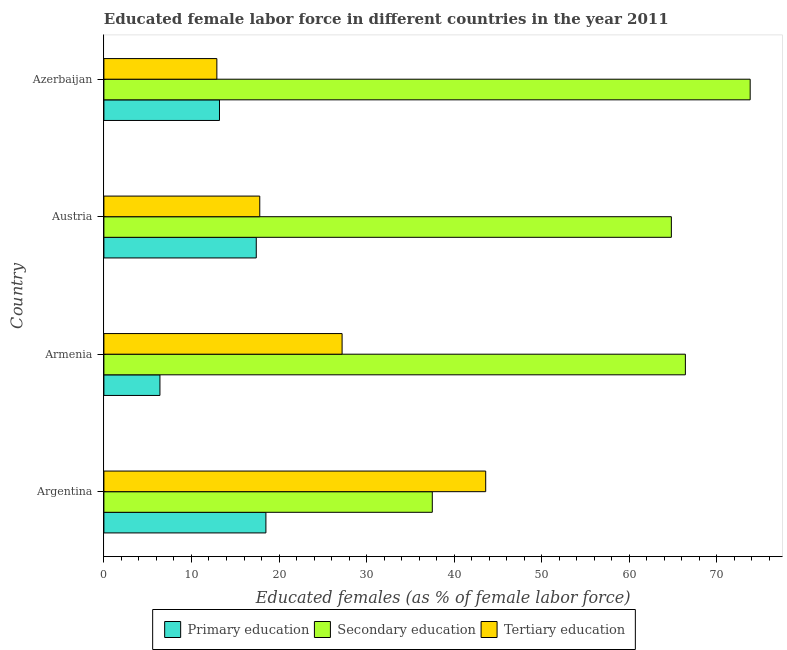How many groups of bars are there?
Provide a succinct answer. 4. What is the label of the 4th group of bars from the top?
Your answer should be compact. Argentina. In how many cases, is the number of bars for a given country not equal to the number of legend labels?
Offer a terse response. 0. What is the percentage of female labor force who received tertiary education in Azerbaijan?
Ensure brevity in your answer.  12.9. Across all countries, what is the maximum percentage of female labor force who received secondary education?
Provide a short and direct response. 73.8. Across all countries, what is the minimum percentage of female labor force who received tertiary education?
Offer a terse response. 12.9. In which country was the percentage of female labor force who received secondary education minimum?
Offer a very short reply. Argentina. What is the total percentage of female labor force who received secondary education in the graph?
Ensure brevity in your answer.  242.5. What is the difference between the percentage of female labor force who received tertiary education in Argentina and that in Austria?
Keep it short and to the point. 25.8. What is the difference between the percentage of female labor force who received secondary education in Austria and the percentage of female labor force who received primary education in Armenia?
Make the answer very short. 58.4. What is the average percentage of female labor force who received primary education per country?
Your answer should be compact. 13.88. What is the difference between the percentage of female labor force who received primary education and percentage of female labor force who received tertiary education in Argentina?
Your answer should be compact. -25.1. What is the ratio of the percentage of female labor force who received tertiary education in Argentina to that in Austria?
Your response must be concise. 2.45. What is the difference between the highest and the lowest percentage of female labor force who received tertiary education?
Your answer should be very brief. 30.7. In how many countries, is the percentage of female labor force who received primary education greater than the average percentage of female labor force who received primary education taken over all countries?
Give a very brief answer. 2. Is the sum of the percentage of female labor force who received tertiary education in Argentina and Austria greater than the maximum percentage of female labor force who received secondary education across all countries?
Offer a very short reply. No. What does the 3rd bar from the bottom in Austria represents?
Your answer should be very brief. Tertiary education. Are all the bars in the graph horizontal?
Give a very brief answer. Yes. How many countries are there in the graph?
Offer a very short reply. 4. What is the difference between two consecutive major ticks on the X-axis?
Give a very brief answer. 10. Are the values on the major ticks of X-axis written in scientific E-notation?
Give a very brief answer. No. Does the graph contain grids?
Offer a very short reply. No. What is the title of the graph?
Provide a succinct answer. Educated female labor force in different countries in the year 2011. Does "Solid fuel" appear as one of the legend labels in the graph?
Your answer should be very brief. No. What is the label or title of the X-axis?
Give a very brief answer. Educated females (as % of female labor force). What is the label or title of the Y-axis?
Your answer should be compact. Country. What is the Educated females (as % of female labor force) in Primary education in Argentina?
Ensure brevity in your answer.  18.5. What is the Educated females (as % of female labor force) in Secondary education in Argentina?
Your response must be concise. 37.5. What is the Educated females (as % of female labor force) of Tertiary education in Argentina?
Offer a very short reply. 43.6. What is the Educated females (as % of female labor force) of Primary education in Armenia?
Your answer should be very brief. 6.4. What is the Educated females (as % of female labor force) in Secondary education in Armenia?
Offer a very short reply. 66.4. What is the Educated females (as % of female labor force) of Tertiary education in Armenia?
Make the answer very short. 27.2. What is the Educated females (as % of female labor force) in Primary education in Austria?
Provide a succinct answer. 17.4. What is the Educated females (as % of female labor force) in Secondary education in Austria?
Ensure brevity in your answer.  64.8. What is the Educated females (as % of female labor force) of Tertiary education in Austria?
Your response must be concise. 17.8. What is the Educated females (as % of female labor force) of Primary education in Azerbaijan?
Your response must be concise. 13.2. What is the Educated females (as % of female labor force) of Secondary education in Azerbaijan?
Provide a succinct answer. 73.8. What is the Educated females (as % of female labor force) in Tertiary education in Azerbaijan?
Your answer should be compact. 12.9. Across all countries, what is the maximum Educated females (as % of female labor force) of Primary education?
Give a very brief answer. 18.5. Across all countries, what is the maximum Educated females (as % of female labor force) of Secondary education?
Make the answer very short. 73.8. Across all countries, what is the maximum Educated females (as % of female labor force) of Tertiary education?
Provide a short and direct response. 43.6. Across all countries, what is the minimum Educated females (as % of female labor force) of Primary education?
Make the answer very short. 6.4. Across all countries, what is the minimum Educated females (as % of female labor force) in Secondary education?
Make the answer very short. 37.5. Across all countries, what is the minimum Educated females (as % of female labor force) in Tertiary education?
Keep it short and to the point. 12.9. What is the total Educated females (as % of female labor force) of Primary education in the graph?
Offer a very short reply. 55.5. What is the total Educated females (as % of female labor force) in Secondary education in the graph?
Offer a very short reply. 242.5. What is the total Educated females (as % of female labor force) in Tertiary education in the graph?
Keep it short and to the point. 101.5. What is the difference between the Educated females (as % of female labor force) in Secondary education in Argentina and that in Armenia?
Your answer should be compact. -28.9. What is the difference between the Educated females (as % of female labor force) in Tertiary education in Argentina and that in Armenia?
Your answer should be very brief. 16.4. What is the difference between the Educated females (as % of female labor force) in Secondary education in Argentina and that in Austria?
Keep it short and to the point. -27.3. What is the difference between the Educated females (as % of female labor force) of Tertiary education in Argentina and that in Austria?
Offer a very short reply. 25.8. What is the difference between the Educated females (as % of female labor force) of Primary education in Argentina and that in Azerbaijan?
Offer a terse response. 5.3. What is the difference between the Educated females (as % of female labor force) of Secondary education in Argentina and that in Azerbaijan?
Offer a terse response. -36.3. What is the difference between the Educated females (as % of female labor force) of Tertiary education in Argentina and that in Azerbaijan?
Offer a terse response. 30.7. What is the difference between the Educated females (as % of female labor force) of Primary education in Armenia and that in Austria?
Your response must be concise. -11. What is the difference between the Educated females (as % of female labor force) of Primary education in Armenia and that in Azerbaijan?
Offer a very short reply. -6.8. What is the difference between the Educated females (as % of female labor force) of Primary education in Austria and that in Azerbaijan?
Ensure brevity in your answer.  4.2. What is the difference between the Educated females (as % of female labor force) in Secondary education in Austria and that in Azerbaijan?
Your answer should be very brief. -9. What is the difference between the Educated females (as % of female labor force) in Tertiary education in Austria and that in Azerbaijan?
Keep it short and to the point. 4.9. What is the difference between the Educated females (as % of female labor force) in Primary education in Argentina and the Educated females (as % of female labor force) in Secondary education in Armenia?
Provide a succinct answer. -47.9. What is the difference between the Educated females (as % of female labor force) of Secondary education in Argentina and the Educated females (as % of female labor force) of Tertiary education in Armenia?
Provide a short and direct response. 10.3. What is the difference between the Educated females (as % of female labor force) in Primary education in Argentina and the Educated females (as % of female labor force) in Secondary education in Austria?
Offer a terse response. -46.3. What is the difference between the Educated females (as % of female labor force) in Secondary education in Argentina and the Educated females (as % of female labor force) in Tertiary education in Austria?
Provide a short and direct response. 19.7. What is the difference between the Educated females (as % of female labor force) in Primary education in Argentina and the Educated females (as % of female labor force) in Secondary education in Azerbaijan?
Offer a very short reply. -55.3. What is the difference between the Educated females (as % of female labor force) in Secondary education in Argentina and the Educated females (as % of female labor force) in Tertiary education in Azerbaijan?
Your answer should be very brief. 24.6. What is the difference between the Educated females (as % of female labor force) of Primary education in Armenia and the Educated females (as % of female labor force) of Secondary education in Austria?
Make the answer very short. -58.4. What is the difference between the Educated females (as % of female labor force) of Primary education in Armenia and the Educated females (as % of female labor force) of Tertiary education in Austria?
Provide a short and direct response. -11.4. What is the difference between the Educated females (as % of female labor force) of Secondary education in Armenia and the Educated females (as % of female labor force) of Tertiary education in Austria?
Your response must be concise. 48.6. What is the difference between the Educated females (as % of female labor force) of Primary education in Armenia and the Educated females (as % of female labor force) of Secondary education in Azerbaijan?
Your response must be concise. -67.4. What is the difference between the Educated females (as % of female labor force) in Secondary education in Armenia and the Educated females (as % of female labor force) in Tertiary education in Azerbaijan?
Your answer should be very brief. 53.5. What is the difference between the Educated females (as % of female labor force) of Primary education in Austria and the Educated females (as % of female labor force) of Secondary education in Azerbaijan?
Your answer should be very brief. -56.4. What is the difference between the Educated females (as % of female labor force) of Secondary education in Austria and the Educated females (as % of female labor force) of Tertiary education in Azerbaijan?
Make the answer very short. 51.9. What is the average Educated females (as % of female labor force) of Primary education per country?
Ensure brevity in your answer.  13.88. What is the average Educated females (as % of female labor force) in Secondary education per country?
Ensure brevity in your answer.  60.62. What is the average Educated females (as % of female labor force) of Tertiary education per country?
Offer a very short reply. 25.38. What is the difference between the Educated females (as % of female labor force) of Primary education and Educated females (as % of female labor force) of Tertiary education in Argentina?
Offer a terse response. -25.1. What is the difference between the Educated females (as % of female labor force) of Primary education and Educated females (as % of female labor force) of Secondary education in Armenia?
Keep it short and to the point. -60. What is the difference between the Educated females (as % of female labor force) of Primary education and Educated females (as % of female labor force) of Tertiary education in Armenia?
Make the answer very short. -20.8. What is the difference between the Educated females (as % of female labor force) of Secondary education and Educated females (as % of female labor force) of Tertiary education in Armenia?
Make the answer very short. 39.2. What is the difference between the Educated females (as % of female labor force) of Primary education and Educated females (as % of female labor force) of Secondary education in Austria?
Ensure brevity in your answer.  -47.4. What is the difference between the Educated females (as % of female labor force) of Secondary education and Educated females (as % of female labor force) of Tertiary education in Austria?
Your response must be concise. 47. What is the difference between the Educated females (as % of female labor force) of Primary education and Educated females (as % of female labor force) of Secondary education in Azerbaijan?
Provide a succinct answer. -60.6. What is the difference between the Educated females (as % of female labor force) of Secondary education and Educated females (as % of female labor force) of Tertiary education in Azerbaijan?
Your answer should be compact. 60.9. What is the ratio of the Educated females (as % of female labor force) in Primary education in Argentina to that in Armenia?
Keep it short and to the point. 2.89. What is the ratio of the Educated females (as % of female labor force) in Secondary education in Argentina to that in Armenia?
Keep it short and to the point. 0.56. What is the ratio of the Educated females (as % of female labor force) in Tertiary education in Argentina to that in Armenia?
Your response must be concise. 1.6. What is the ratio of the Educated females (as % of female labor force) of Primary education in Argentina to that in Austria?
Give a very brief answer. 1.06. What is the ratio of the Educated females (as % of female labor force) of Secondary education in Argentina to that in Austria?
Give a very brief answer. 0.58. What is the ratio of the Educated females (as % of female labor force) in Tertiary education in Argentina to that in Austria?
Ensure brevity in your answer.  2.45. What is the ratio of the Educated females (as % of female labor force) in Primary education in Argentina to that in Azerbaijan?
Ensure brevity in your answer.  1.4. What is the ratio of the Educated females (as % of female labor force) of Secondary education in Argentina to that in Azerbaijan?
Ensure brevity in your answer.  0.51. What is the ratio of the Educated females (as % of female labor force) in Tertiary education in Argentina to that in Azerbaijan?
Offer a terse response. 3.38. What is the ratio of the Educated females (as % of female labor force) of Primary education in Armenia to that in Austria?
Keep it short and to the point. 0.37. What is the ratio of the Educated females (as % of female labor force) in Secondary education in Armenia to that in Austria?
Make the answer very short. 1.02. What is the ratio of the Educated females (as % of female labor force) of Tertiary education in Armenia to that in Austria?
Provide a succinct answer. 1.53. What is the ratio of the Educated females (as % of female labor force) of Primary education in Armenia to that in Azerbaijan?
Keep it short and to the point. 0.48. What is the ratio of the Educated females (as % of female labor force) in Secondary education in Armenia to that in Azerbaijan?
Offer a very short reply. 0.9. What is the ratio of the Educated females (as % of female labor force) in Tertiary education in Armenia to that in Azerbaijan?
Offer a very short reply. 2.11. What is the ratio of the Educated females (as % of female labor force) of Primary education in Austria to that in Azerbaijan?
Make the answer very short. 1.32. What is the ratio of the Educated females (as % of female labor force) of Secondary education in Austria to that in Azerbaijan?
Provide a succinct answer. 0.88. What is the ratio of the Educated females (as % of female labor force) in Tertiary education in Austria to that in Azerbaijan?
Provide a short and direct response. 1.38. What is the difference between the highest and the second highest Educated females (as % of female labor force) in Primary education?
Your answer should be very brief. 1.1. What is the difference between the highest and the second highest Educated females (as % of female labor force) in Secondary education?
Your response must be concise. 7.4. What is the difference between the highest and the lowest Educated females (as % of female labor force) of Primary education?
Make the answer very short. 12.1. What is the difference between the highest and the lowest Educated females (as % of female labor force) of Secondary education?
Your answer should be compact. 36.3. What is the difference between the highest and the lowest Educated females (as % of female labor force) of Tertiary education?
Give a very brief answer. 30.7. 